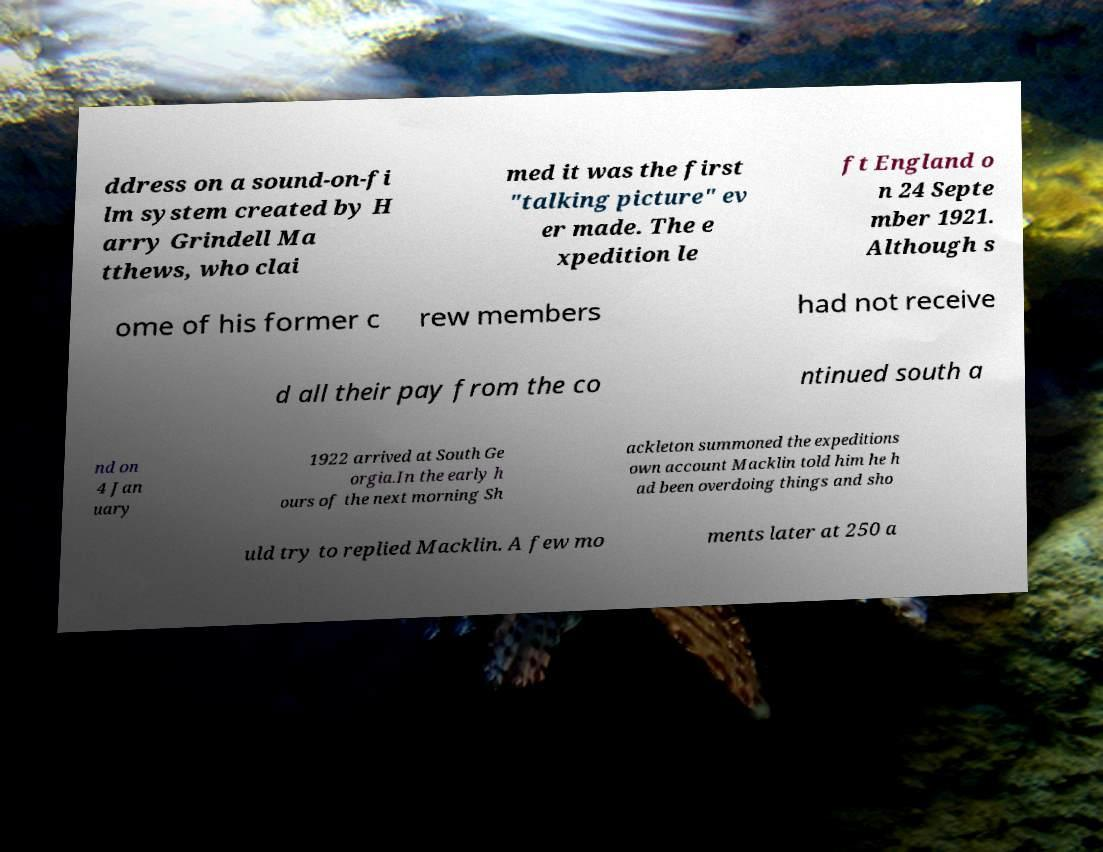For documentation purposes, I need the text within this image transcribed. Could you provide that? ddress on a sound-on-fi lm system created by H arry Grindell Ma tthews, who clai med it was the first "talking picture" ev er made. The e xpedition le ft England o n 24 Septe mber 1921. Although s ome of his former c rew members had not receive d all their pay from the co ntinued south a nd on 4 Jan uary 1922 arrived at South Ge orgia.In the early h ours of the next morning Sh ackleton summoned the expeditions own account Macklin told him he h ad been overdoing things and sho uld try to replied Macklin. A few mo ments later at 250 a 